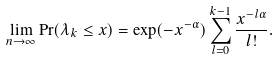<formula> <loc_0><loc_0><loc_500><loc_500>\lim _ { n \to \infty } \Pr ( \lambda _ { k } \leq x ) = \exp ( - x ^ { - \alpha } ) \sum _ { l = 0 } ^ { k - 1 } \frac { x ^ { - l \alpha } } { l ! } .</formula> 